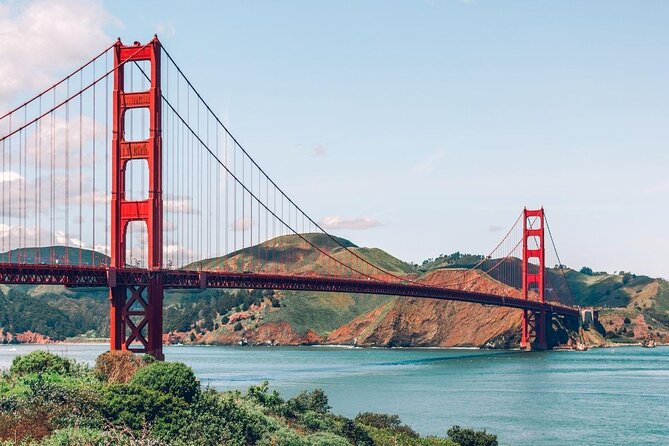What do you think is going on in this snapshot? This image showcases the world-famous Golden Gate Bridge, an architectural marvel that spans the vibrant San Francisco Bay. The bridge's iconic international orange color strikingly contrasts with the lush green hillsides and the clear azure sky. It stands as a testament to human ingenuity, connecting the city of San Francisco with Marin County. The view from the shore provides a picturesque scene where nature and engineering coexist beautifully. In the distance, the undulating hills enhance the breathtaking backdrop, emphasizing the seamless blend of natural and man-made beauty. 